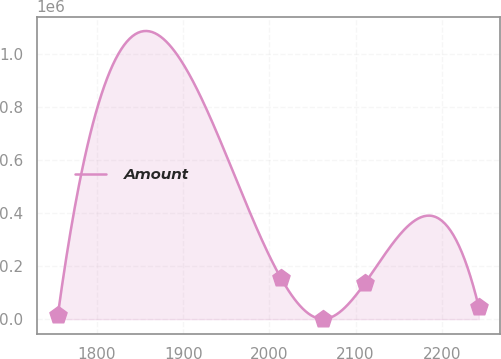Convert chart. <chart><loc_0><loc_0><loc_500><loc_500><line_chart><ecel><fcel>Amount<nl><fcel>1754.57<fcel>15738.8<nl><fcel>2013.59<fcel>154022<nl><fcel>2062.43<fcel>374.01<nl><fcel>2111.27<fcel>137973<nl><fcel>2242.94<fcel>45888.2<nl></chart> 